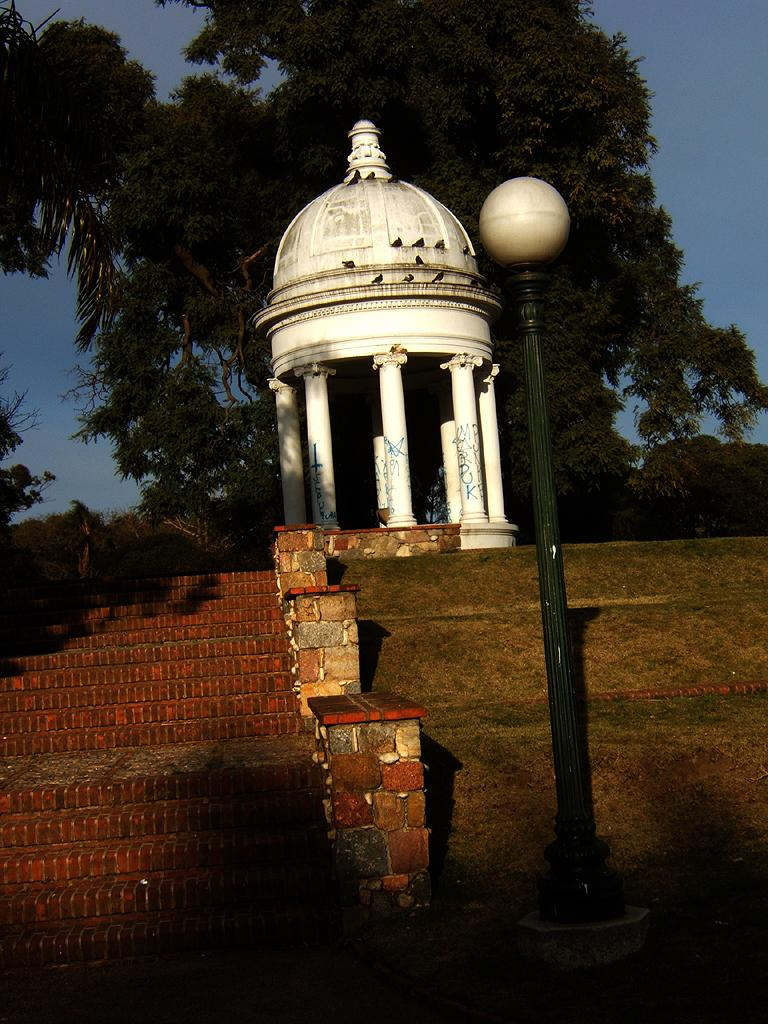What is located in the foreground of the image? In the foreground of the image, there are stairs, a pole, grass land, and a shelter-like architecture. Can you describe the shelter-like architecture in the image? The shelter-like architecture in the foreground of the image is a prominent feature. What can be seen at the top of the image? At the top of the image, there are trees and the sky is visible. What type of map can be seen on the grass land in the image? There is no map present on the grass land in the image. Can you hear the dog barking in the image? There is no dog present in the image, so it cannot be heard. 